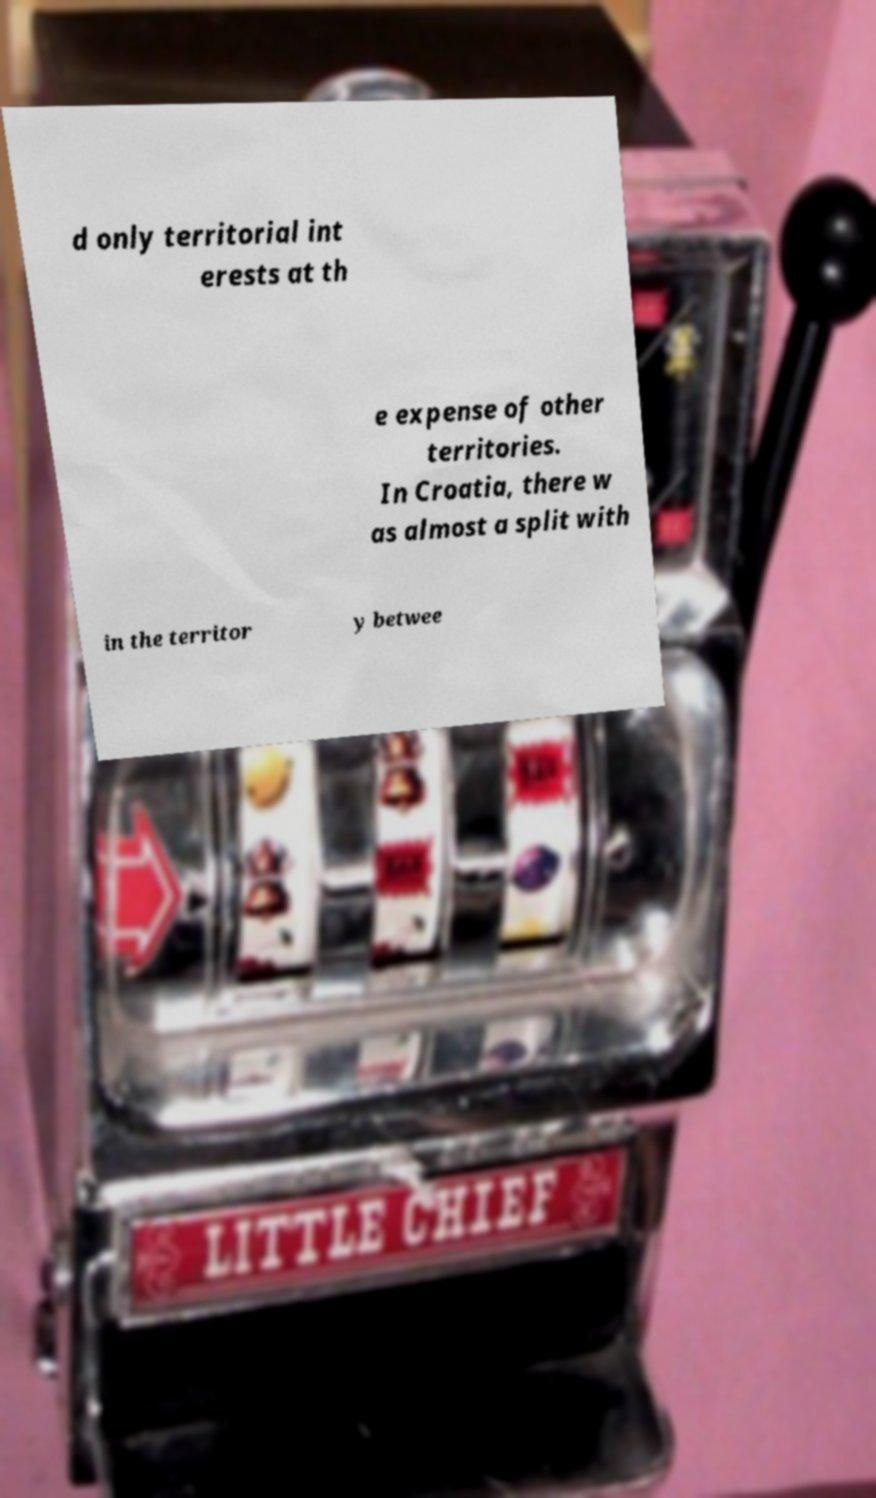There's text embedded in this image that I need extracted. Can you transcribe it verbatim? d only territorial int erests at th e expense of other territories. In Croatia, there w as almost a split with in the territor y betwee 